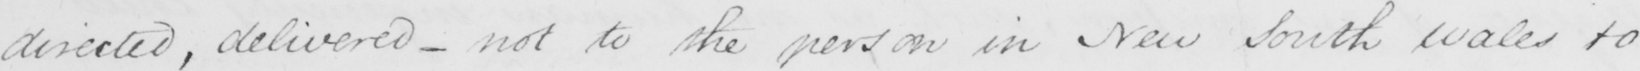Can you tell me what this handwritten text says? directed , delivered  _  not to the person in New South Wales to 